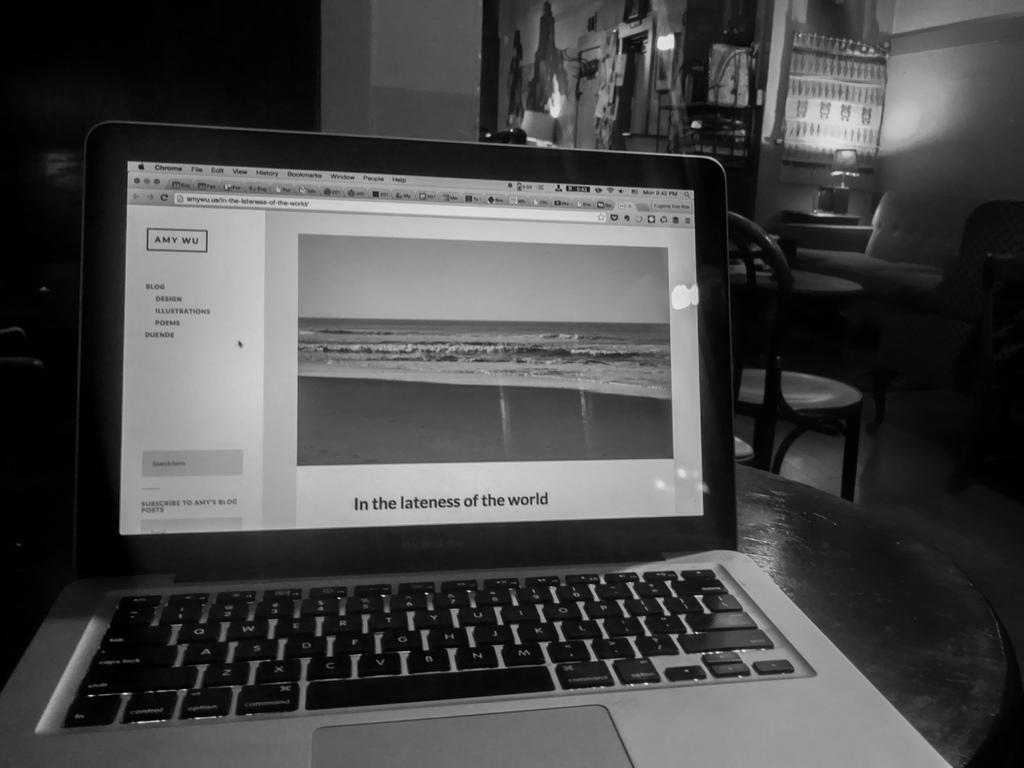<image>
Provide a brief description of the given image. The article on the laptop computer talks about the lateness of the world. 